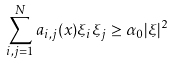<formula> <loc_0><loc_0><loc_500><loc_500>\sum _ { i , j = 1 } ^ { N } a _ { i , j } ( x ) \xi _ { i } \xi _ { j } \geq \alpha _ { 0 } | \xi | ^ { 2 }</formula> 